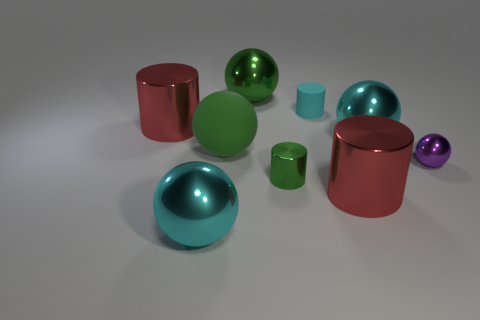Does the large object that is behind the tiny cyan thing have the same color as the large rubber ball in front of the matte cylinder?
Offer a very short reply. Yes. What number of other things are the same color as the small rubber cylinder?
Provide a short and direct response. 2. What number of tiny metallic objects have the same shape as the small cyan matte object?
Offer a very short reply. 1. What is the size of the green thing that is made of the same material as the tiny cyan thing?
Make the answer very short. Large. There is a large cylinder that is left of the big red object that is on the right side of the cyan cylinder; is there a matte cylinder left of it?
Provide a succinct answer. No. There is a cyan thing that is in front of the green matte ball; does it have the same size as the small purple thing?
Give a very brief answer. No. What number of cyan objects are the same size as the green metal cylinder?
Your answer should be compact. 1. There is a rubber object that is the same color as the small metal cylinder; what is its size?
Ensure brevity in your answer.  Large. Is the color of the small metallic ball the same as the small matte cylinder?
Ensure brevity in your answer.  No. The big green rubber object has what shape?
Make the answer very short. Sphere. 